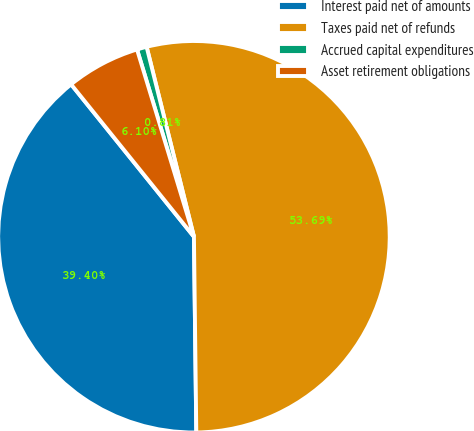Convert chart to OTSL. <chart><loc_0><loc_0><loc_500><loc_500><pie_chart><fcel>Interest paid net of amounts<fcel>Taxes paid net of refunds<fcel>Accrued capital expenditures<fcel>Asset retirement obligations<nl><fcel>39.4%<fcel>53.7%<fcel>0.81%<fcel>6.1%<nl></chart> 